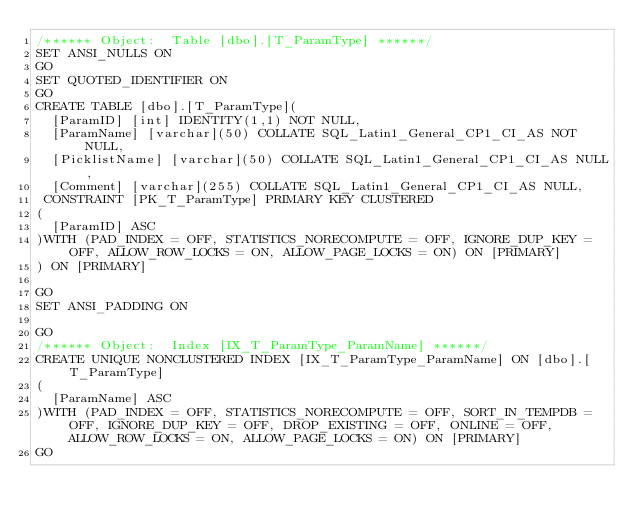Convert code to text. <code><loc_0><loc_0><loc_500><loc_500><_SQL_>/****** Object:  Table [dbo].[T_ParamType] ******/
SET ANSI_NULLS ON
GO
SET QUOTED_IDENTIFIER ON
GO
CREATE TABLE [dbo].[T_ParamType](
	[ParamID] [int] IDENTITY(1,1) NOT NULL,
	[ParamName] [varchar](50) COLLATE SQL_Latin1_General_CP1_CI_AS NOT NULL,
	[PicklistName] [varchar](50) COLLATE SQL_Latin1_General_CP1_CI_AS NULL,
	[Comment] [varchar](255) COLLATE SQL_Latin1_General_CP1_CI_AS NULL,
 CONSTRAINT [PK_T_ParamType] PRIMARY KEY CLUSTERED 
(
	[ParamID] ASC
)WITH (PAD_INDEX = OFF, STATISTICS_NORECOMPUTE = OFF, IGNORE_DUP_KEY = OFF, ALLOW_ROW_LOCKS = ON, ALLOW_PAGE_LOCKS = ON) ON [PRIMARY]
) ON [PRIMARY]

GO
SET ANSI_PADDING ON

GO
/****** Object:  Index [IX_T_ParamType_ParamName] ******/
CREATE UNIQUE NONCLUSTERED INDEX [IX_T_ParamType_ParamName] ON [dbo].[T_ParamType]
(
	[ParamName] ASC
)WITH (PAD_INDEX = OFF, STATISTICS_NORECOMPUTE = OFF, SORT_IN_TEMPDB = OFF, IGNORE_DUP_KEY = OFF, DROP_EXISTING = OFF, ONLINE = OFF, ALLOW_ROW_LOCKS = ON, ALLOW_PAGE_LOCKS = ON) ON [PRIMARY]
GO
</code> 